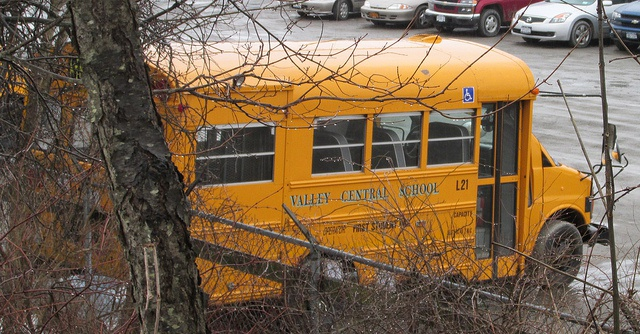Describe the objects in this image and their specific colors. I can see bus in gray, black, olive, and maroon tones, car in gray, lightgray, black, and darkgray tones, truck in gray, black, maroon, and darkgray tones, car in gray, lightgray, black, and darkgray tones, and truck in gray, black, lightblue, and lightgray tones in this image. 